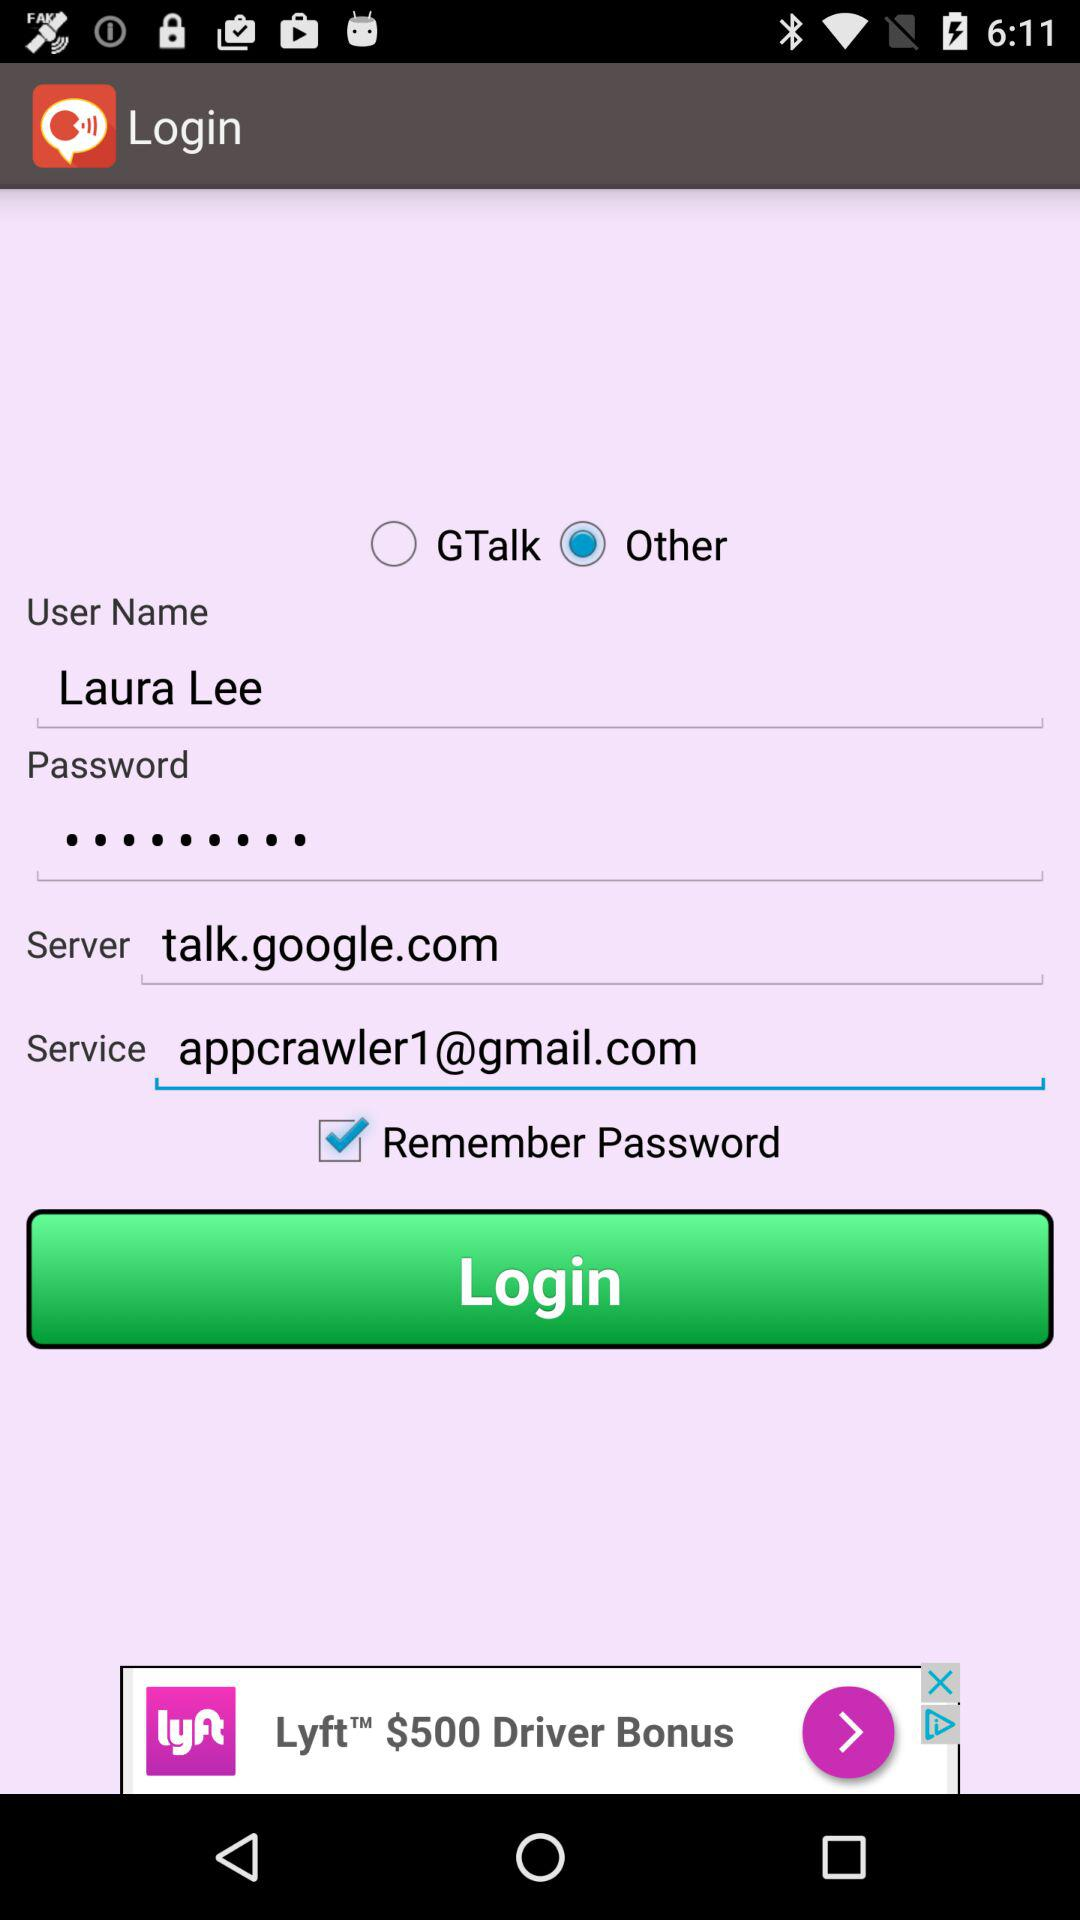What is the user name? The user name is Laura Lee. 